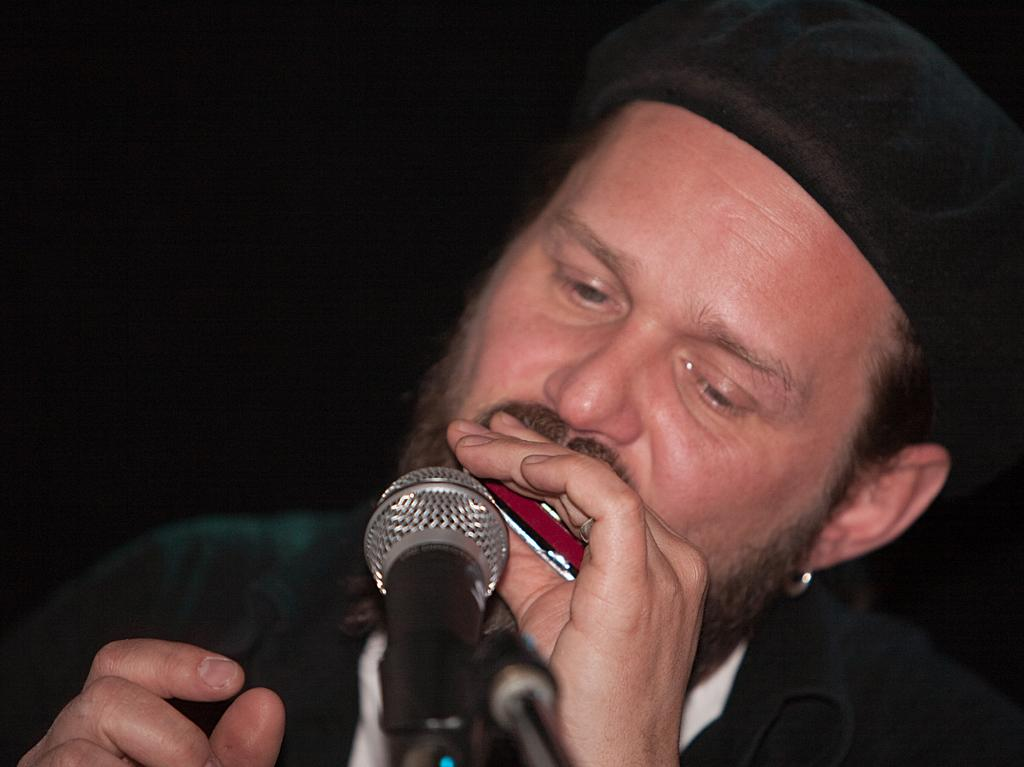Who is the main subject in the image? There is a man in the center of the image. What is the man doing in the image? The man is singing in the image. What is the man holding in the image? The man is holding an object in the image. What is the man wearing on his head? The man is wearing a hat in the image. What can be seen at the bottom of the image? There is a microphone at the bottom of the image. How would you describe the background of the image? The background of the image is dark. Can you tell me how many jellyfish are swimming in the background of the image? There are no jellyfish present in the image; the background is dark. What type of territory does the man's grandmother own in the image? There is no mention of a grandmother or territory in the image. 